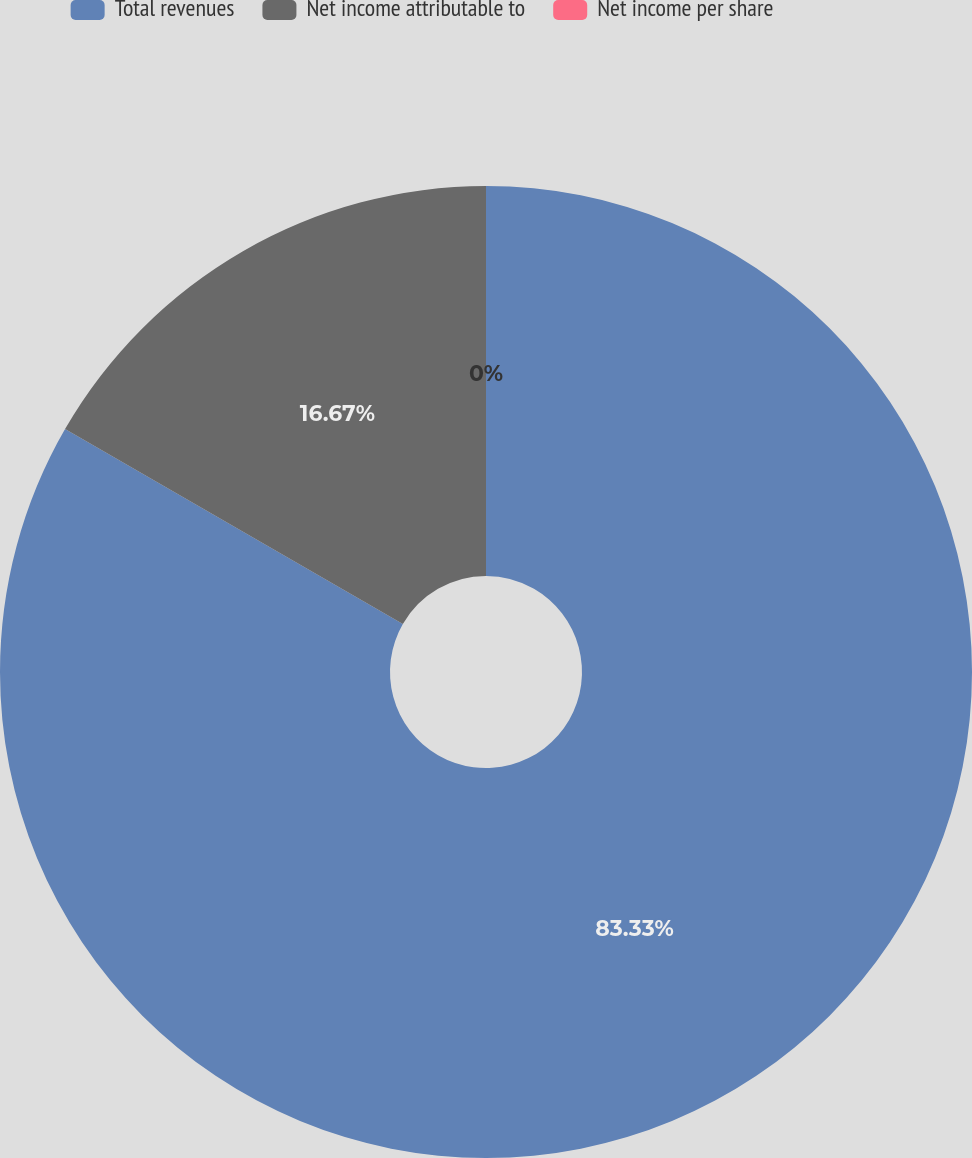Convert chart. <chart><loc_0><loc_0><loc_500><loc_500><pie_chart><fcel>Total revenues<fcel>Net income attributable to<fcel>Net income per share<nl><fcel>83.33%<fcel>16.67%<fcel>0.0%<nl></chart> 